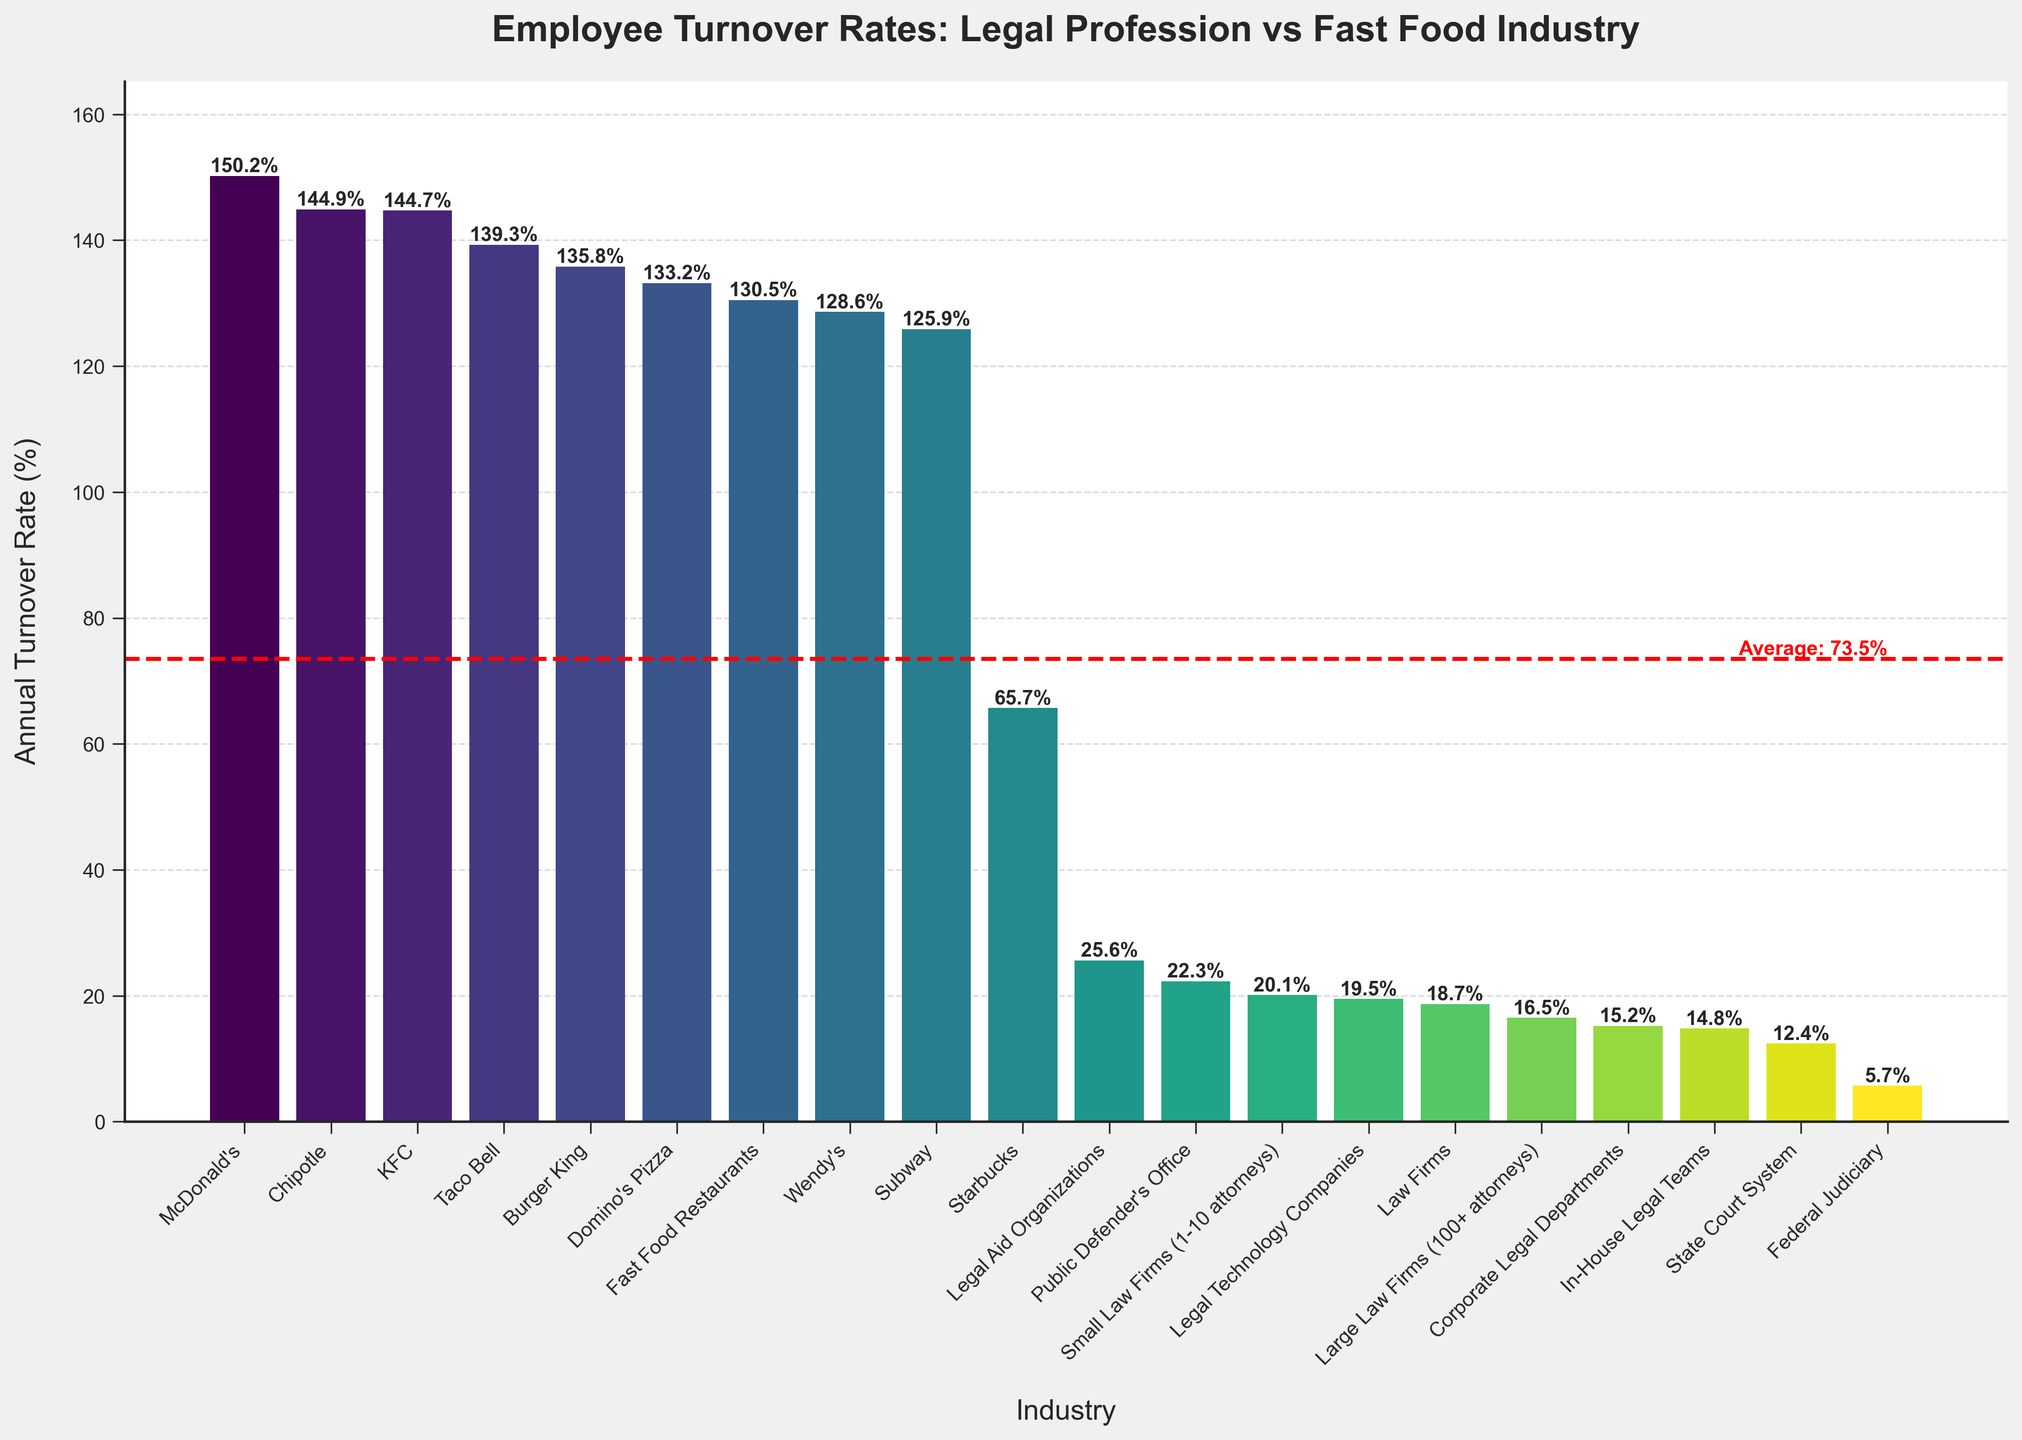Which industry has the highest annual turnover rate? The bar with the highest height represents McDonald's with an annual turnover rate of 150.2%
Answer: McDonald's How does the turnover rate at McDonald's compare to the Federal Judiciary? The turnover rate at McDonald's is 150.2%, significantly higher than the Federal Judiciary's rate of 5.7%.
Answer: McDonald's is much higher What is the difference between the turnover rates of Burger King and Wendy's? Burger King's turnover rate is 135.8% and Wendy's is 128.6%. The difference is 135.8 - 128.6 = 7.2%
Answer: 7.2% What are the industries with turnover rates below 20%? The bars that are below the 20% line are Corporate Legal Departments (15.2%), Large Law Firms (16.5%), In-House Legal Teams (14.8%), and Legal Technology Companies (19.5%)
Answer: Corporate Legal Departments, Large Law Firms, In-House Legal Teams, Legal Technology Companies Which has a higher turnover rate: the Public Defender’s Office or Legal Aid Organizations? The Public Defender's Office has a turnover rate of 22.3%, whereas Legal Aid Organizations have a rate of 25.6%. Therefore, Legal Aid Organizations have a higher turnover rate.
Answer: Legal Aid Organizations What is the average annual turnover rate across all industries? The average is represented by the red dashed line on the figure. According to the text next to this line, the average turnover rate is approximately 62.3%
Answer: 62.3% By how much does the turnover rate at Starbucks differ from that of Taco Bell? Starbucks has a turnover rate of 65.7%, and Taco Bell has a turnover rate of 139.3%. The difference is 139.3 - 65.7 = 73.6%
Answer: 73.6% Which industry has a lower turnover rate: Small Law Firms or Large Law Firms? Small Law Firms have a turnover rate of 20.1%, while Large Law Firms have a turnover rate of 16.5%.
Answer: Large Law Firms Are there any fast food chains with a turnover rate below 130%? If so, which ones? The bars for fast food chains below the 130% line are Wendy's (128.6%) and Subway (125.9%)
Answer: Wendy's, Subway 